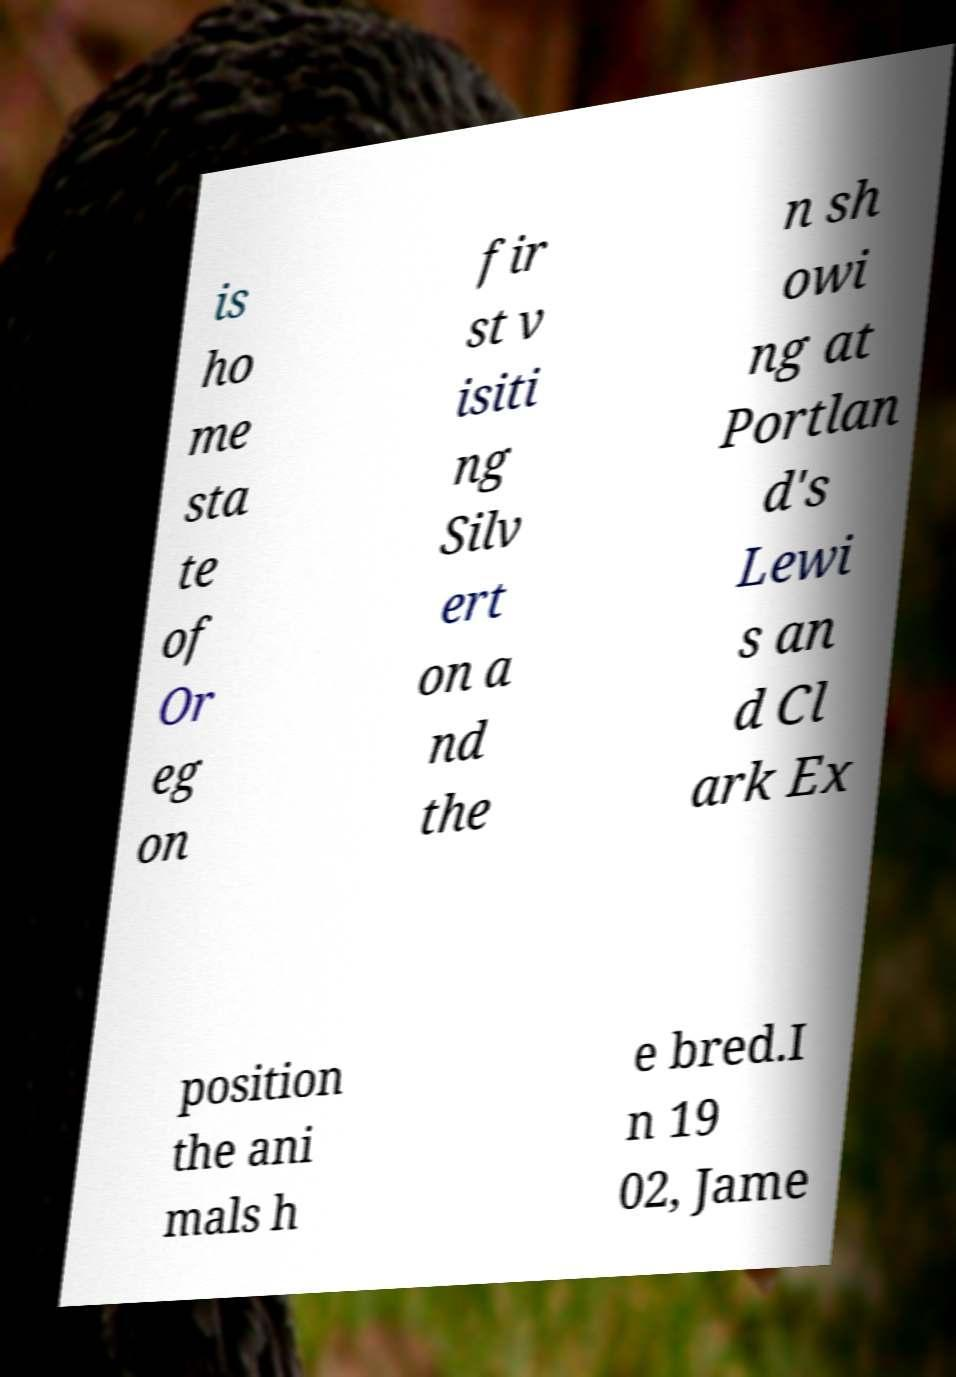Could you extract and type out the text from this image? is ho me sta te of Or eg on fir st v isiti ng Silv ert on a nd the n sh owi ng at Portlan d's Lewi s an d Cl ark Ex position the ani mals h e bred.I n 19 02, Jame 